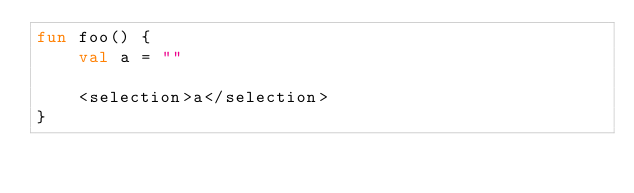<code> <loc_0><loc_0><loc_500><loc_500><_Kotlin_>fun foo() {
    val a = ""

    <selection>a</selection>
}</code> 